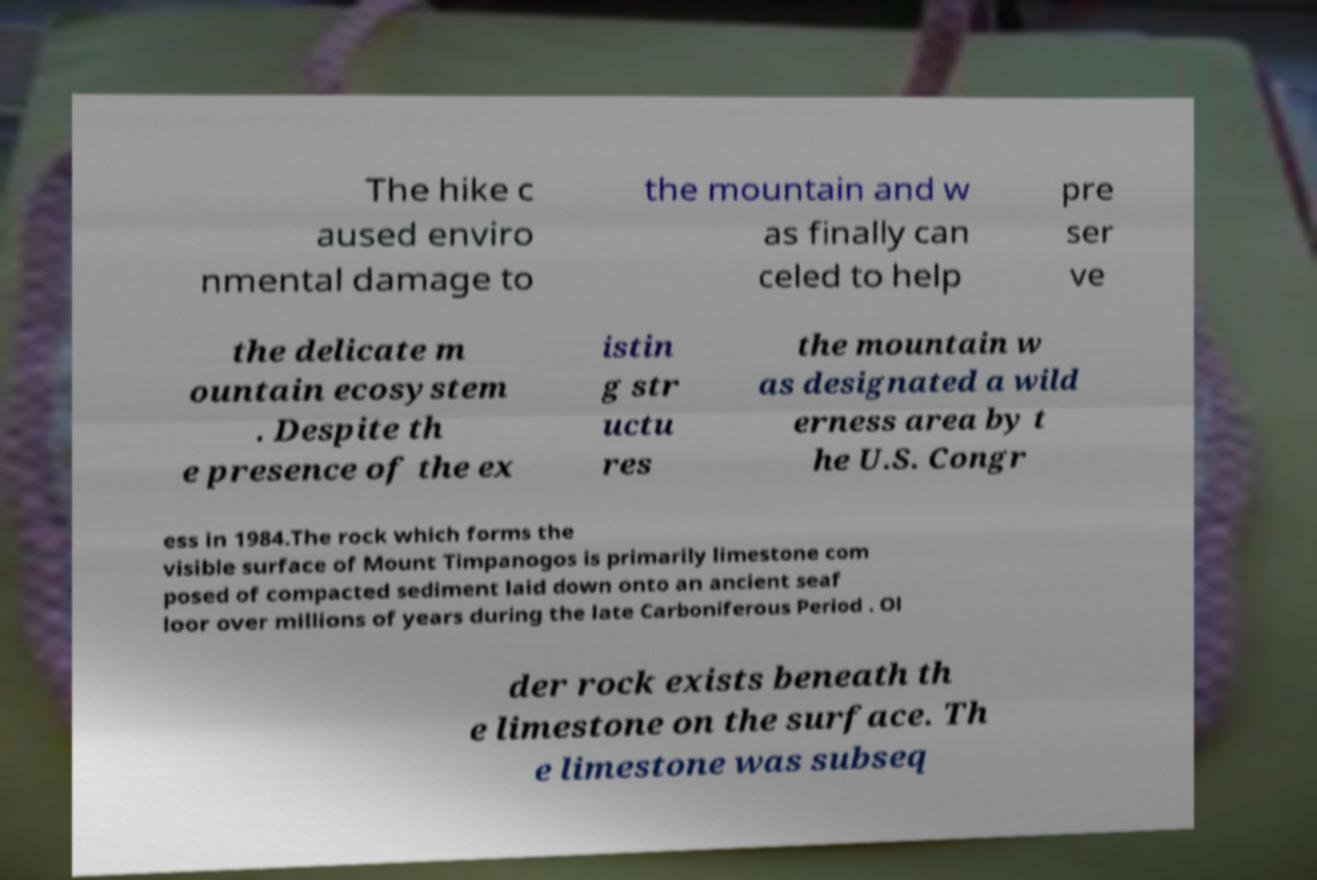Can you read and provide the text displayed in the image?This photo seems to have some interesting text. Can you extract and type it out for me? The hike c aused enviro nmental damage to the mountain and w as finally can celed to help pre ser ve the delicate m ountain ecosystem . Despite th e presence of the ex istin g str uctu res the mountain w as designated a wild erness area by t he U.S. Congr ess in 1984.The rock which forms the visible surface of Mount Timpanogos is primarily limestone com posed of compacted sediment laid down onto an ancient seaf loor over millions of years during the late Carboniferous Period . Ol der rock exists beneath th e limestone on the surface. Th e limestone was subseq 